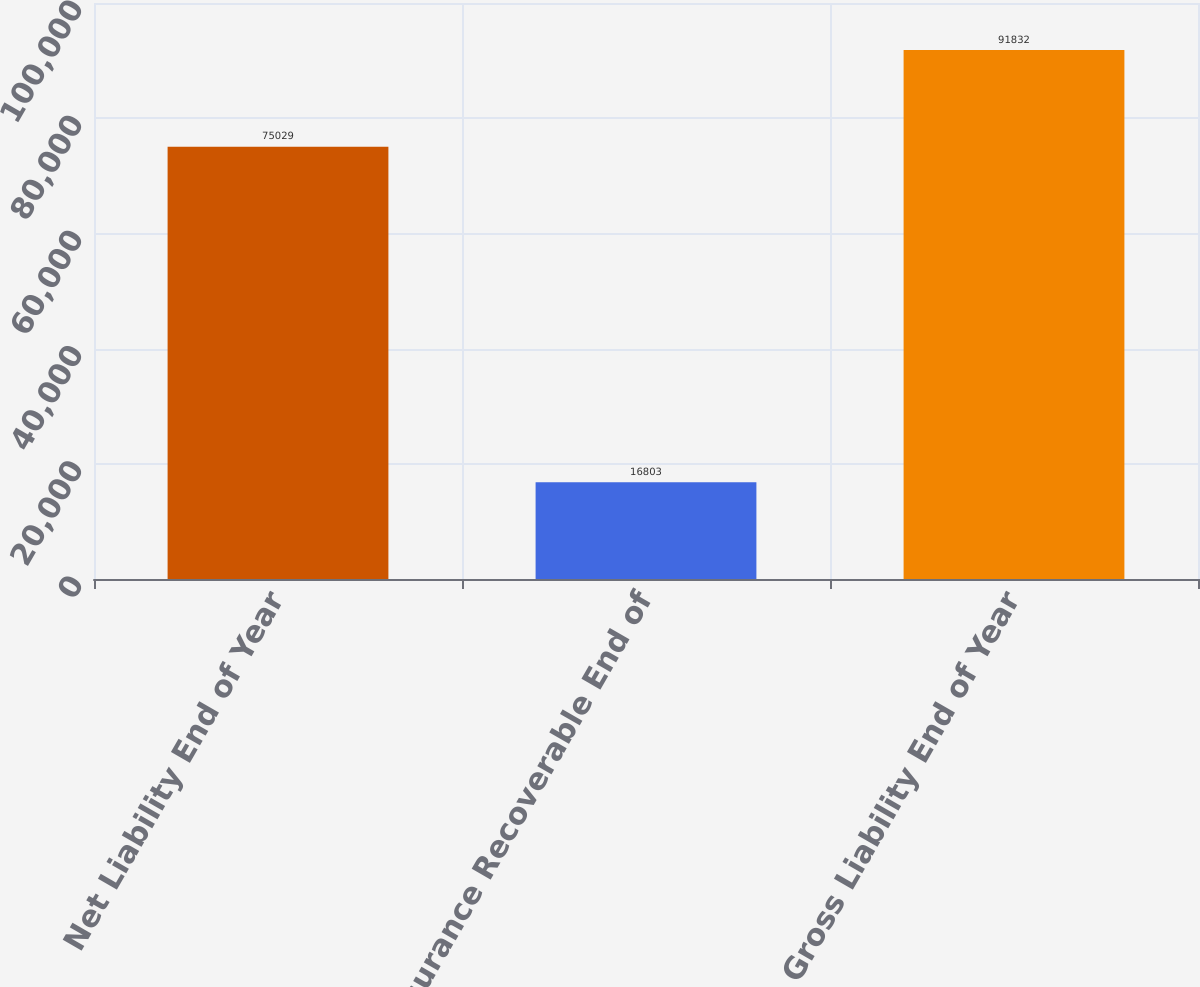<chart> <loc_0><loc_0><loc_500><loc_500><bar_chart><fcel>Net Liability End of Year<fcel>Reinsurance Recoverable End of<fcel>Gross Liability End of Year<nl><fcel>75029<fcel>16803<fcel>91832<nl></chart> 